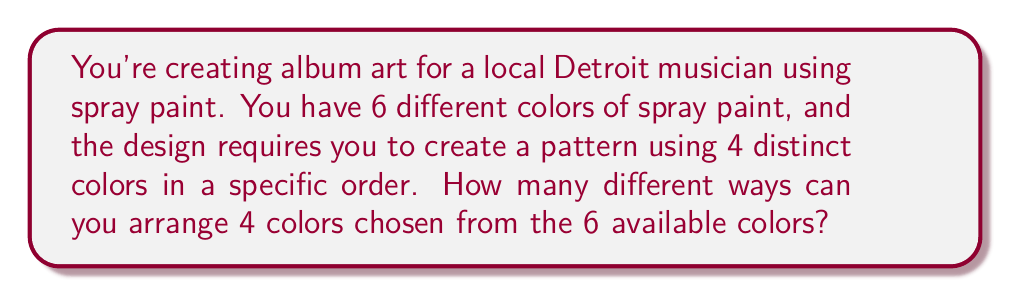Can you answer this question? Let's approach this step-by-step:

1) First, we need to choose 4 colors out of the 6 available colors. This is a combination problem, represented by $\binom{6}{4}$.

   $$\binom{6}{4} = \frac{6!}{4!(6-4)!} = \frac{6!}{4!2!} = 15$$

2) Now that we've chosen 4 colors, we need to arrange them in a specific order. This is a permutation of 4 items, which is simply 4!.

   $$4! = 4 \times 3 \times 2 \times 1 = 24$$

3) By the multiplication principle, the total number of ways to choose 4 colors out of 6 and then arrange them is:

   $$15 \times 24 = 360$$

This can also be represented as a single formula:

$$\binom{6}{4} \times 4! = \frac{6!}{4!(6-4)!} \times 4! = \frac{6!}{2!} = 360$$
Answer: 360 